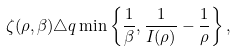Convert formula to latex. <formula><loc_0><loc_0><loc_500><loc_500>\zeta ( \rho , \beta ) \triangle q \min \left \{ \frac { 1 } { \beta } , \frac { 1 } { I ( \rho ) } - \frac { 1 } { \rho } \right \} ,</formula> 